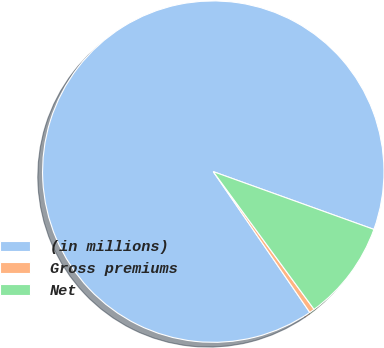Convert chart. <chart><loc_0><loc_0><loc_500><loc_500><pie_chart><fcel>(in millions)<fcel>Gross premiums<fcel>Net<nl><fcel>90.06%<fcel>0.49%<fcel>9.45%<nl></chart> 